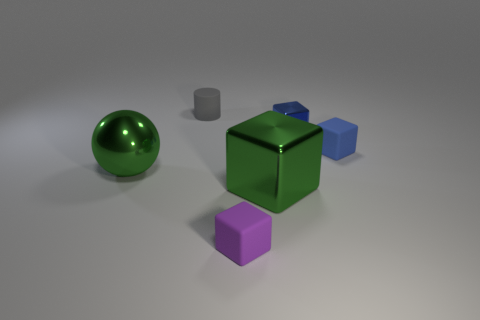Subtract all tiny purple cubes. How many cubes are left? 3 Subtract all spheres. How many objects are left? 5 Subtract all purple blocks. How many blocks are left? 3 Subtract 1 cylinders. How many cylinders are left? 0 Subtract all red balls. Subtract all green cubes. How many balls are left? 1 Subtract all green cubes. How many cyan balls are left? 0 Subtract all yellow matte spheres. Subtract all tiny gray cylinders. How many objects are left? 5 Add 2 big green balls. How many big green balls are left? 3 Add 2 green metal things. How many green metal things exist? 4 Add 2 purple cylinders. How many objects exist? 8 